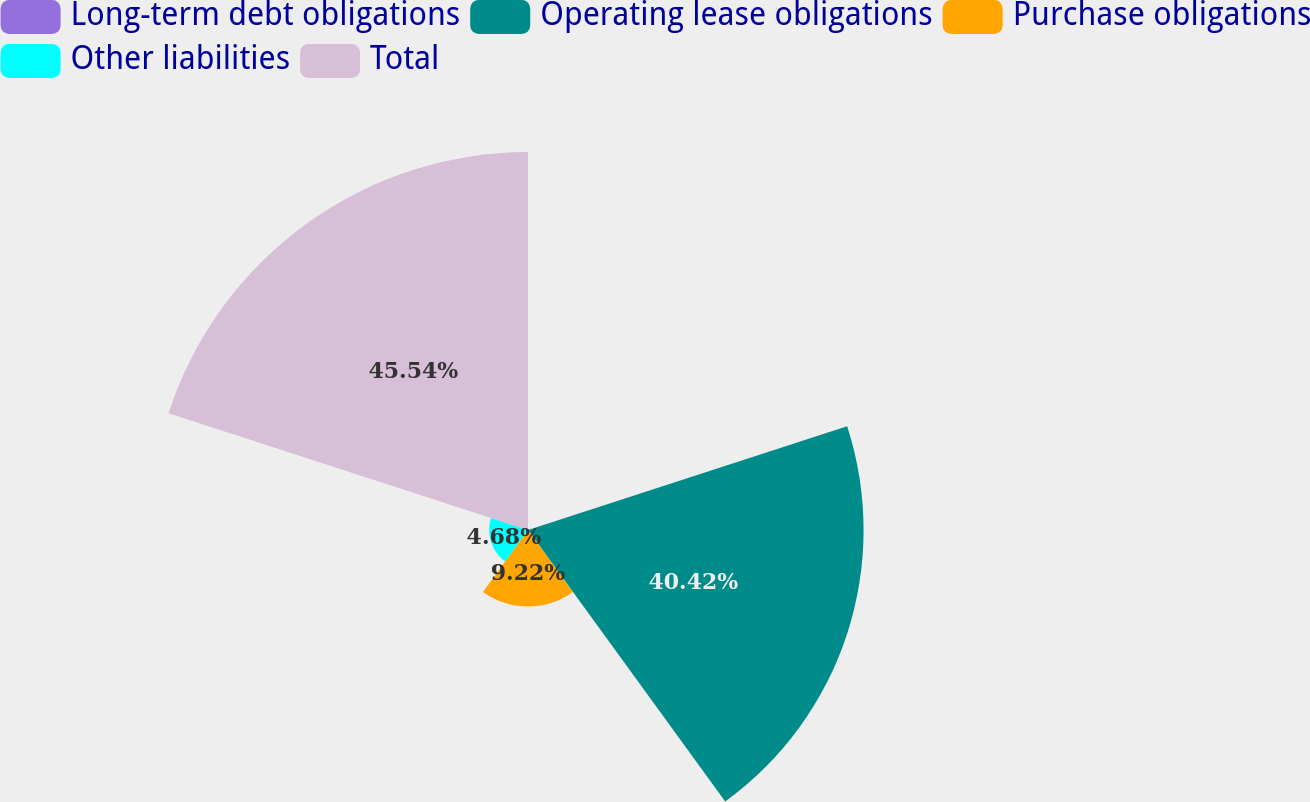Convert chart to OTSL. <chart><loc_0><loc_0><loc_500><loc_500><pie_chart><fcel>Long-term debt obligations<fcel>Operating lease obligations<fcel>Purchase obligations<fcel>Other liabilities<fcel>Total<nl><fcel>0.14%<fcel>40.42%<fcel>9.22%<fcel>4.68%<fcel>45.53%<nl></chart> 